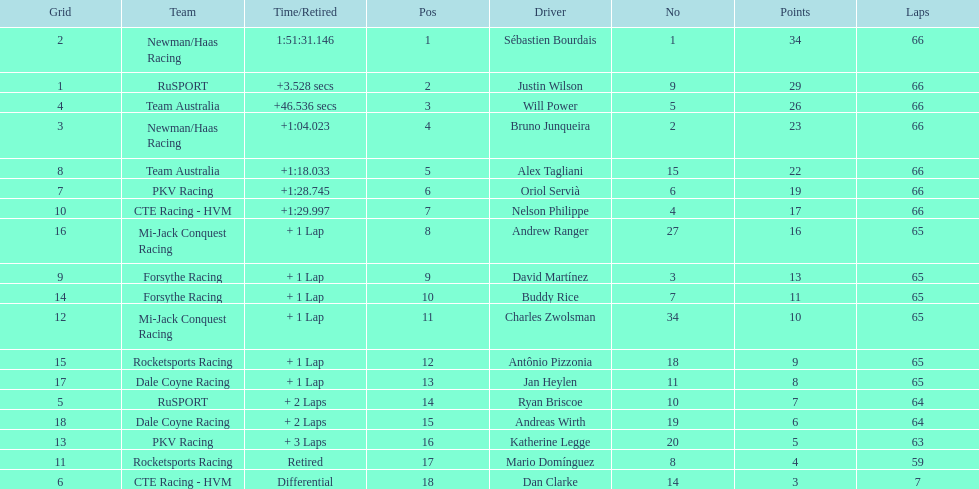How many points did first place receive? 34. How many did last place receive? 3. Who was the recipient of these last place points? Dan Clarke. 